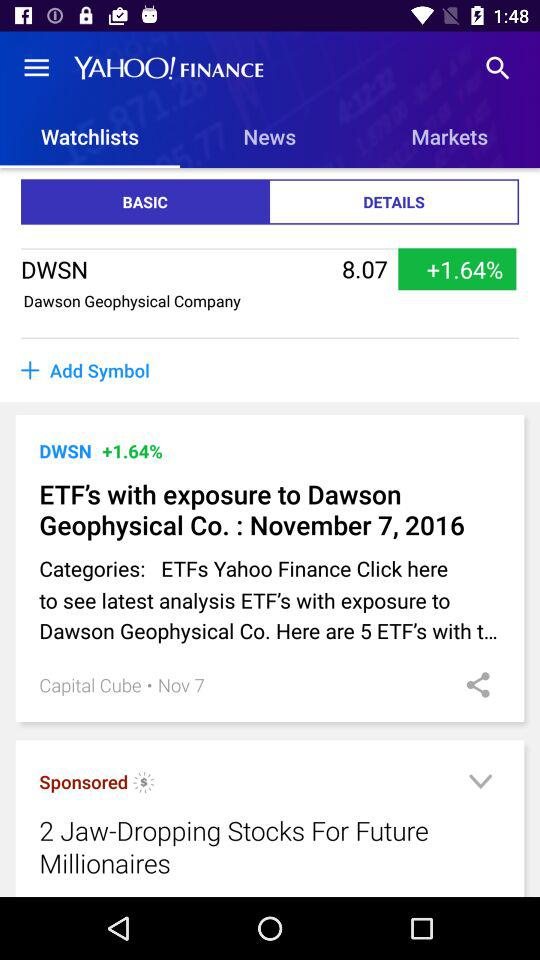What percentage is mentioned in DWSN? The percentage mentioned is +1.64. 